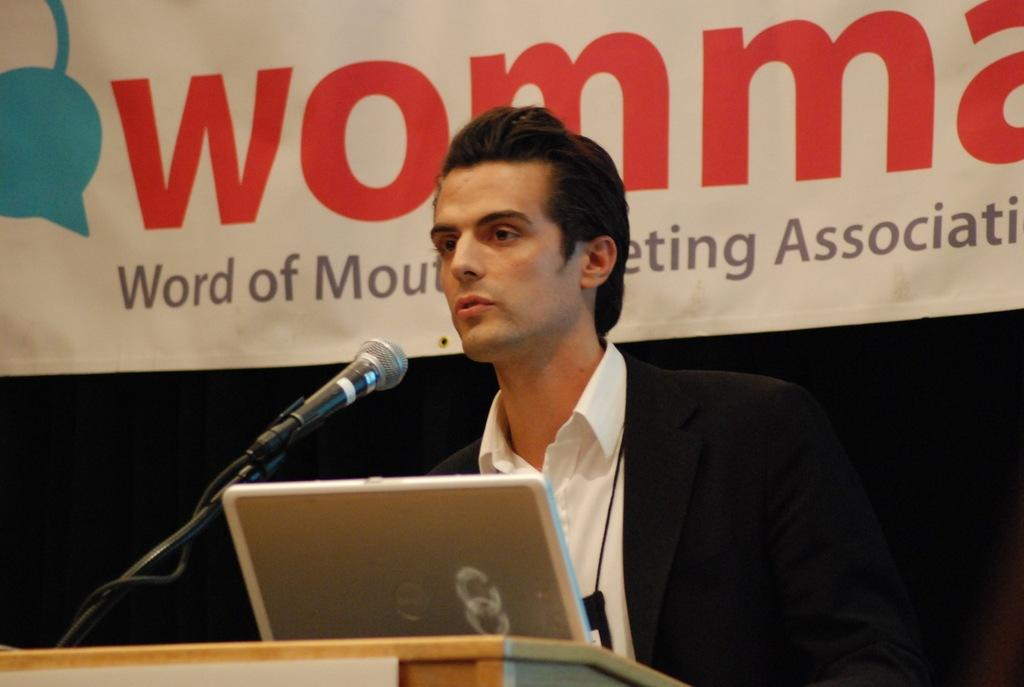What is the main subject of the image? There is a person in the image. What is the person wearing? The person is wearing a suit. Does the person have any identification in the image? Yes, the person has an ID card. What can be seen in the background of the image? There is a banner in the background of the image. What electronic device is visible in the image? There is a laptop in the image. What object might be used for amplifying sound in the image? There is a microphone in the image. What type of lettuce is being used as a tablecloth in the image? There is no lettuce present in the image, and it is not being used as a tablecloth. What type of care is the person providing in the image? The image does not depict any care being provided; it shows a person wearing a suit with an ID card, a laptop, and a microphone. 